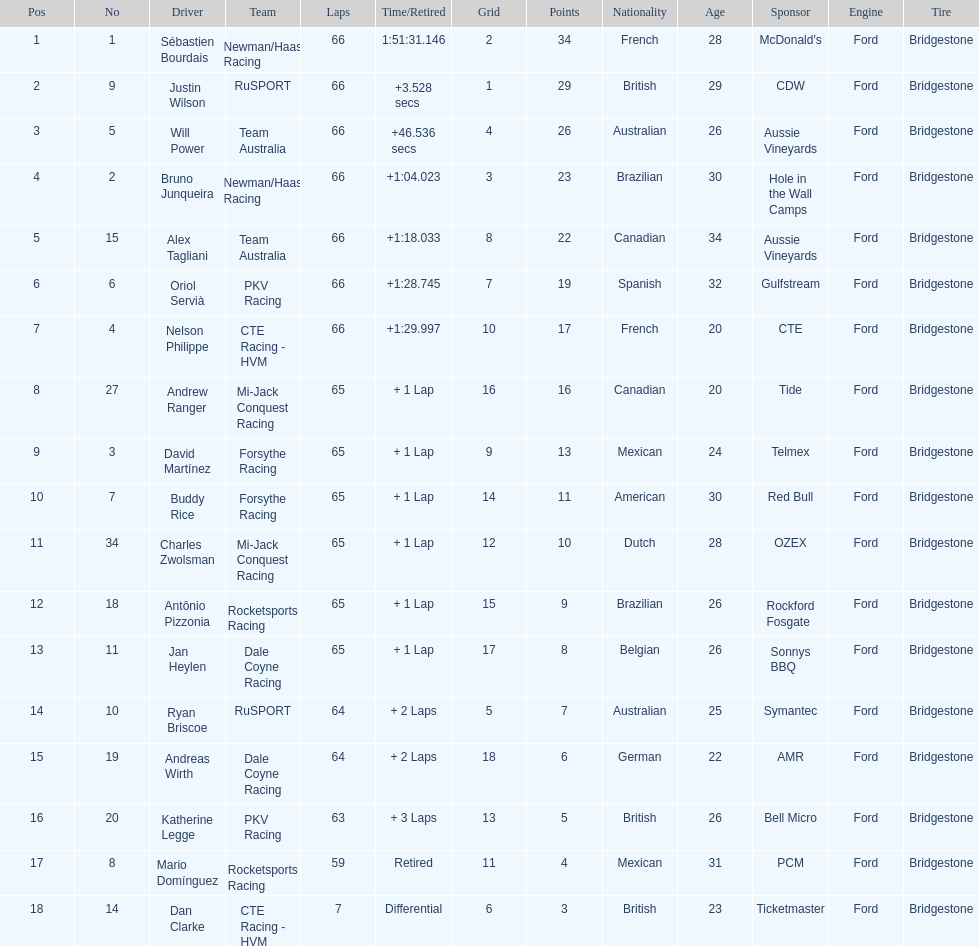Which country had more drivers representing them, the us or germany? Tie. 